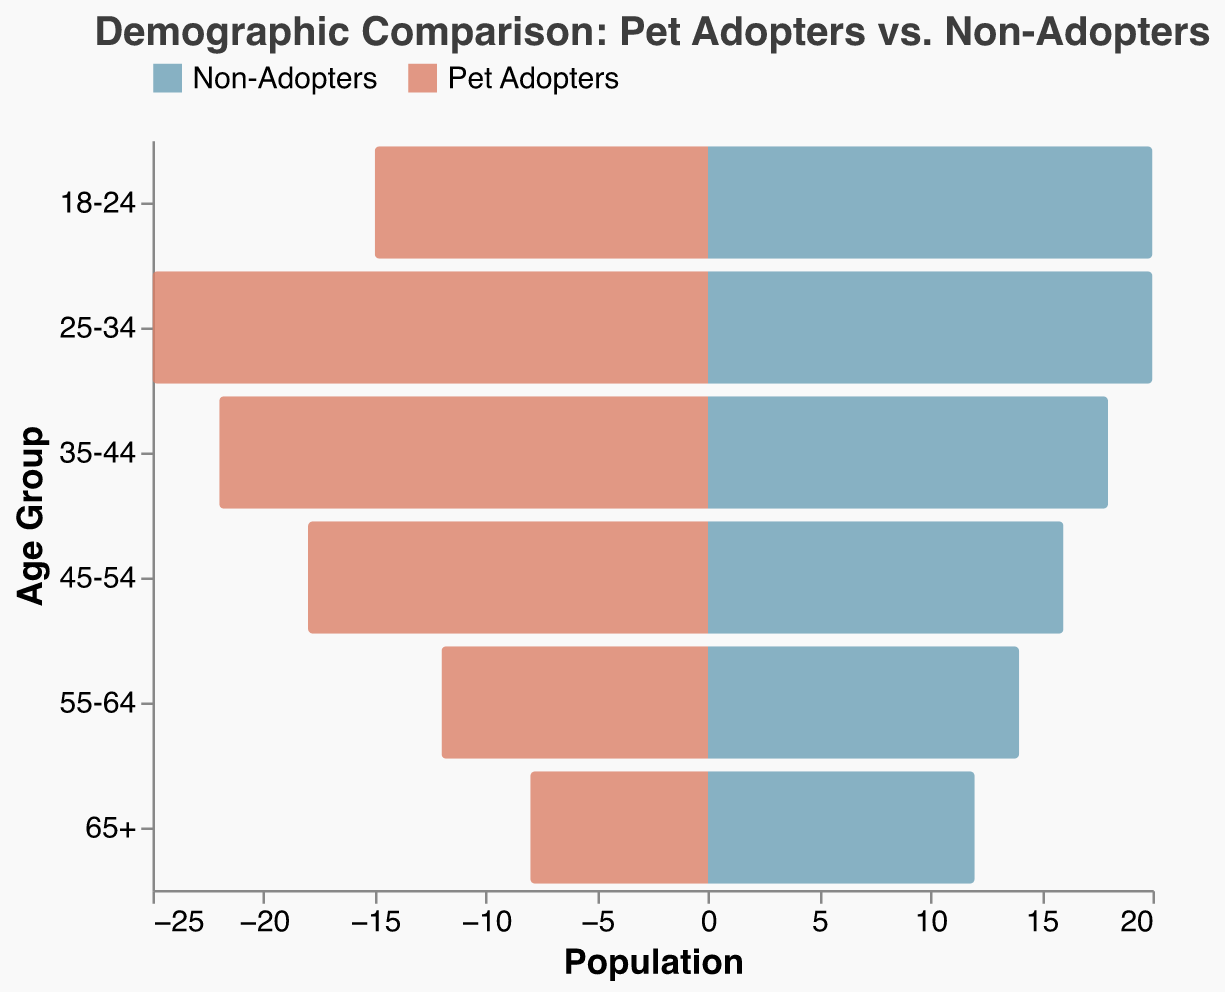Which age group has the highest number of pet adopters? From the figure, the highest bar on the negative side (representing Pet Adopters) is in the age group 25-34.
Answer: 25-34 How many more pet adopters are there in the 35-44 age group compared to the 18-24 age group? The number of pet adopters in the 35-44 age group is 22, and in the 18-24 age group, it is 15. The difference is 22 - 15.
Answer: 7 Which age group has a higher number of non-adopters, 45-54 or 55-64? From the figure, the bar for non-adopters in the 45-54 age group is slightly smaller than in the 55-64 age group, with values of 16 and 14 respectively.
Answer: 45-54 What is the total number of pet adopters across all age groups? Summing up the values for pet adopters: 8 (65+) + 12 (55-64) + 18 (45-54) + 22 (35-44) + 25 (25-34) + 15 (18-24) = 100.
Answer: 100 Compare the age group 25-34 with 65+; how many more non-adopters are there in 65+ compared to 25-34? The number of non-adopters in the 65+ age group is 12, and in the 25-34 age group, it is 20. Therefore, the difference is 20 - 12.
Answer: 8 In which age group is the difference between pet adopters and non-adopters the smallest? The difference between pet adopters and non-adopters is the smallest in the 55-64 age group, where it is 14 (non-adopters) - 12 (pet adopters) = 2.
Answer: 55-64 What are the cumulative totals for non-adopters in the age groups below 45 years? Summing up the values for non-adopters below 45 years (45-54 is excluded): 20 (18-24) + 20 (25-34) + 18 (35-44) = 58.
Answer: 58 